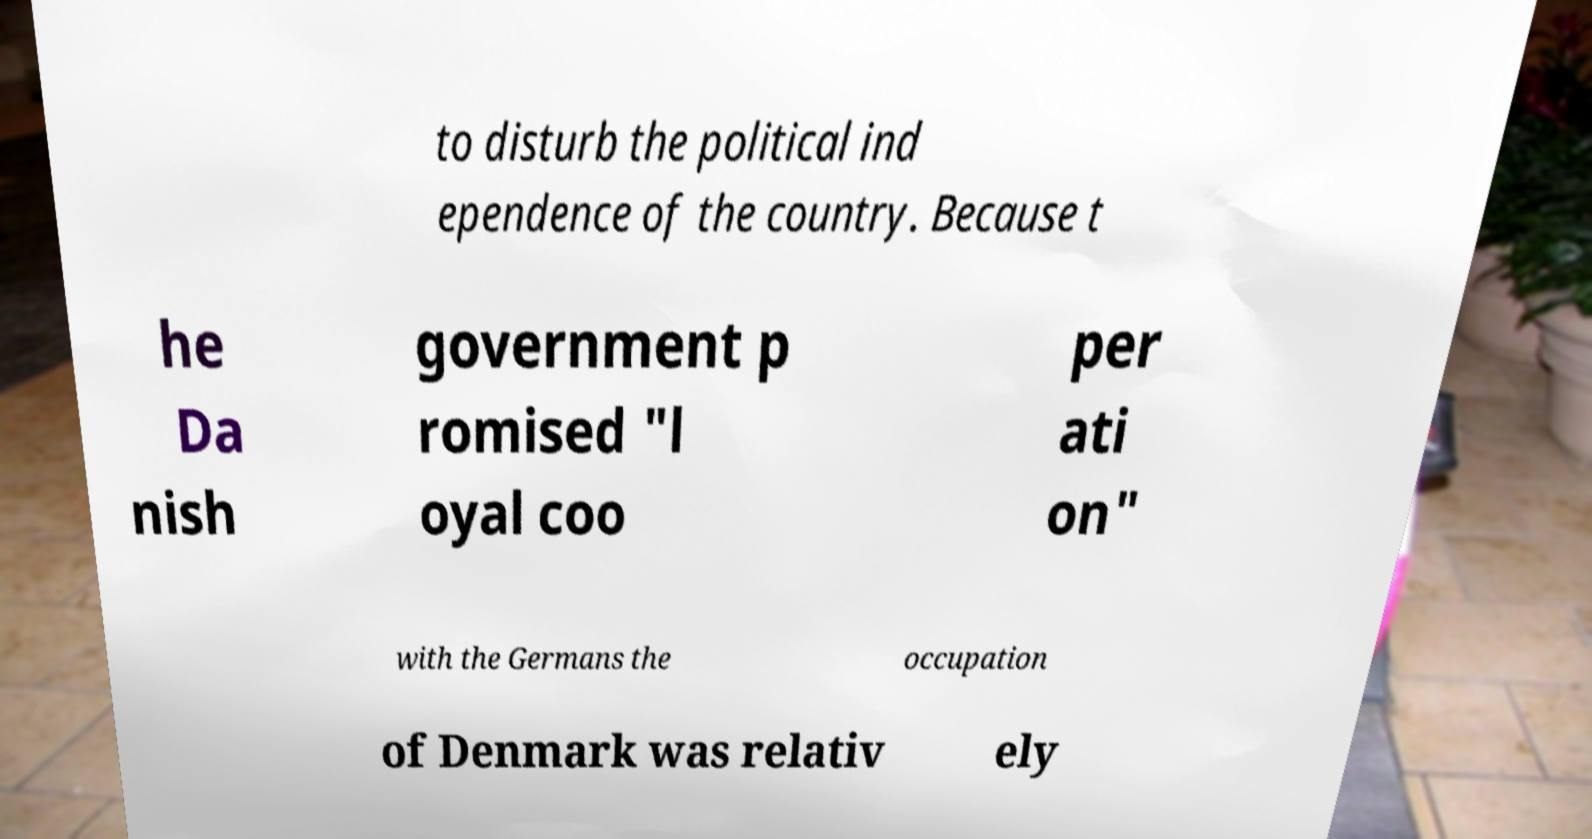Please identify and transcribe the text found in this image. to disturb the political ind ependence of the country. Because t he Da nish government p romised "l oyal coo per ati on" with the Germans the occupation of Denmark was relativ ely 